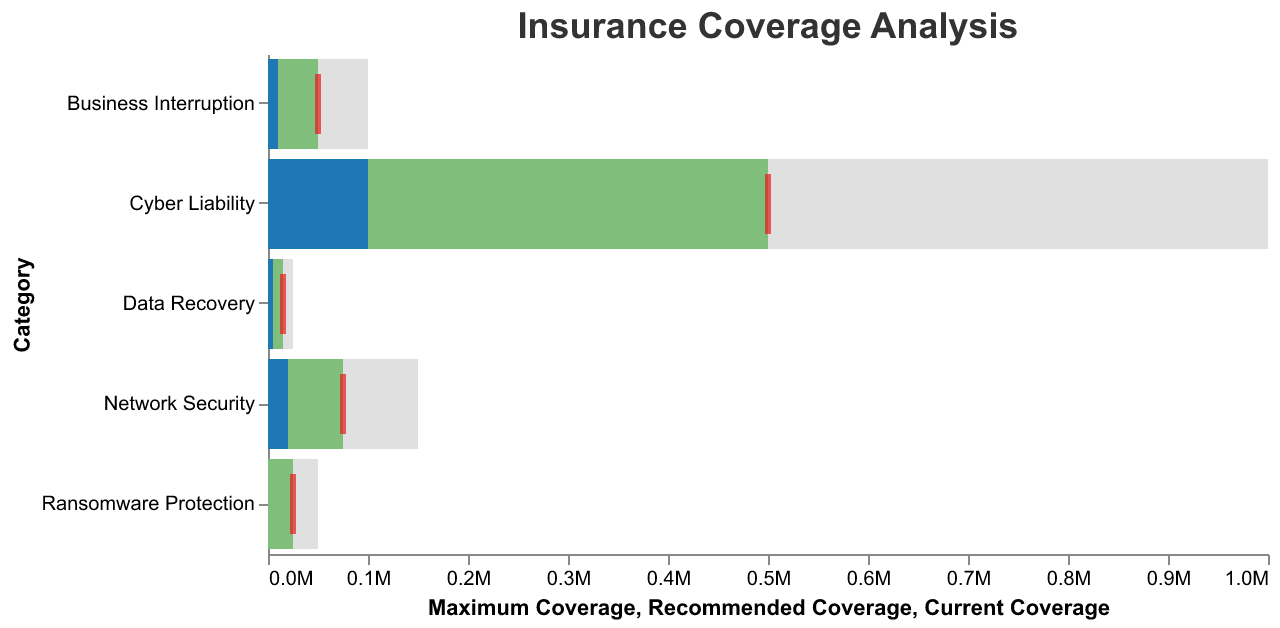How many coverage categories are displayed in the figure? There are five distinct categories listed in the visualization.
Answer: 5 What is the title of the figure? The title of the figure is displayed at the top as "Insurance Coverage Analysis."
Answer: Insurance Coverage Analysis Which category has the highest recommended coverage? By looking at the length of the green bars for each category, the "Cyber Liability" category has the longest bar, indicating the highest recommended coverage.
Answer: Cyber Liability What is the difference between the recommended and current coverage amounts for Network Security? The recommended coverage for Network Security is $75,000, and the current coverage is $20,000. The difference is $75,000 - $20,000 = $55,000.
Answer: $55,000 Which coverage category has no current coverage but has a recommended coverage? The Ransomware Protection category has a recommended coverage of $25,000 but a current coverage of $0, as indicated by the absence of the blue bar and the presence of the green bar and red tick marks.
Answer: Ransomware Protection What is the maximum coverage amount for Business Interruption? From the figure, the maximum coverage amount for Business Interruption is the end of the gray bar, which is $100,000.
Answer: $100,000 If you sum all the current coverages across all categories, what is the total amount? The current coverages are $5000, $100,000, $10,000, 0, and $20,000 respectively. Summing these amounts gives $5,000 + $100,000 + $10,000 + $0 + $20,000 = $135,000.
Answer: $135,000 Which category requires the most increase in coverage from current to recommended amounts and by how much? The Cyber Liability category has a recommended coverage of $500,000 and a current coverage of $100,000. To find the increase, calculate $500,000 - $100,000 = $400,000.
Answer: Cyber Liability, $400,000 Which categories have current coverage but the current amount is below the recommended amount? By comparing the blue and green bars, Data Recovery, Cyber Liability, Business Interruption, and Network Security all have current coverage that is below their recommended values.
Answer: Data Recovery, Cyber Liability, Business Interruption, Network Security 